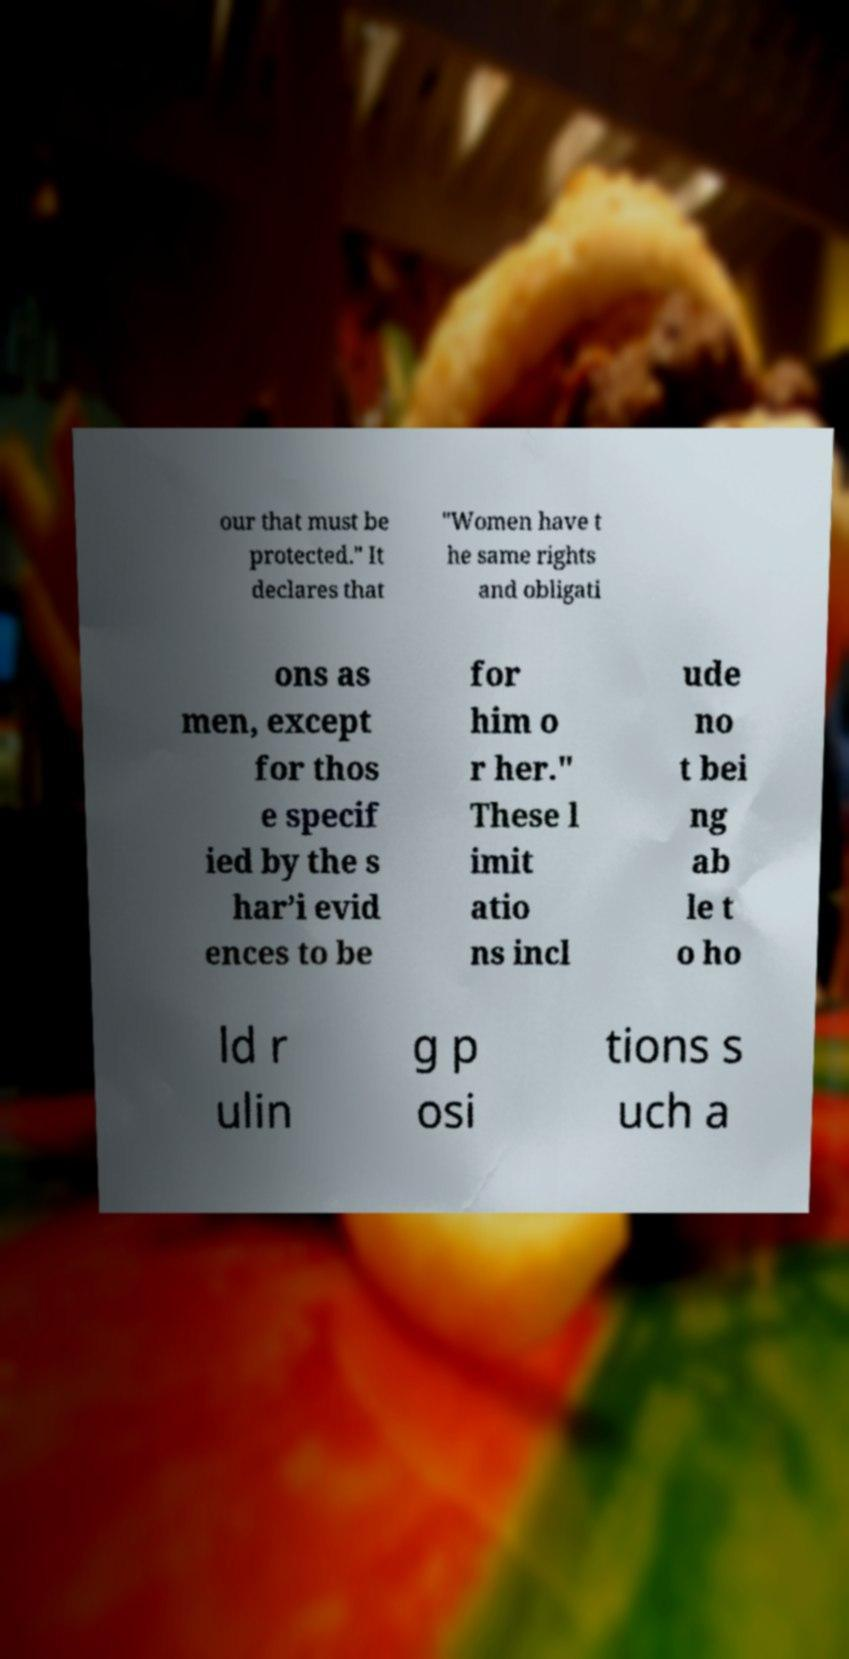Could you extract and type out the text from this image? our that must be protected." It declares that "Women have t he same rights and obligati ons as men, except for thos e specif ied by the s har’i evid ences to be for him o r her." These l imit atio ns incl ude no t bei ng ab le t o ho ld r ulin g p osi tions s uch a 